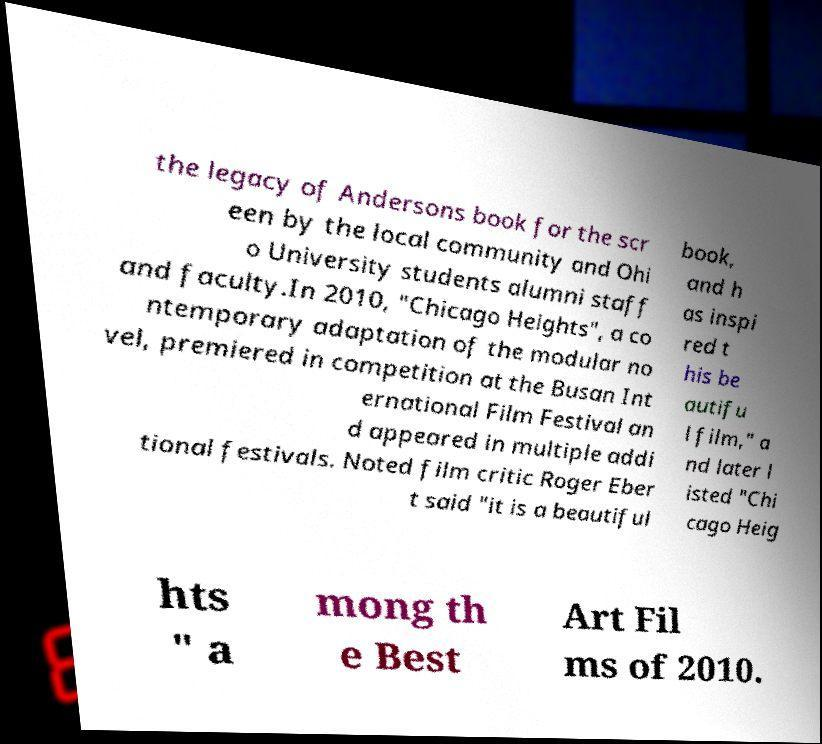There's text embedded in this image that I need extracted. Can you transcribe it verbatim? the legacy of Andersons book for the scr een by the local community and Ohi o University students alumni staff and faculty.In 2010, "Chicago Heights", a co ntemporary adaptation of the modular no vel, premiered in competition at the Busan Int ernational Film Festival an d appeared in multiple addi tional festivals. Noted film critic Roger Eber t said "it is a beautiful book, and h as inspi red t his be autifu l film," a nd later l isted "Chi cago Heig hts " a mong th e Best Art Fil ms of 2010. 